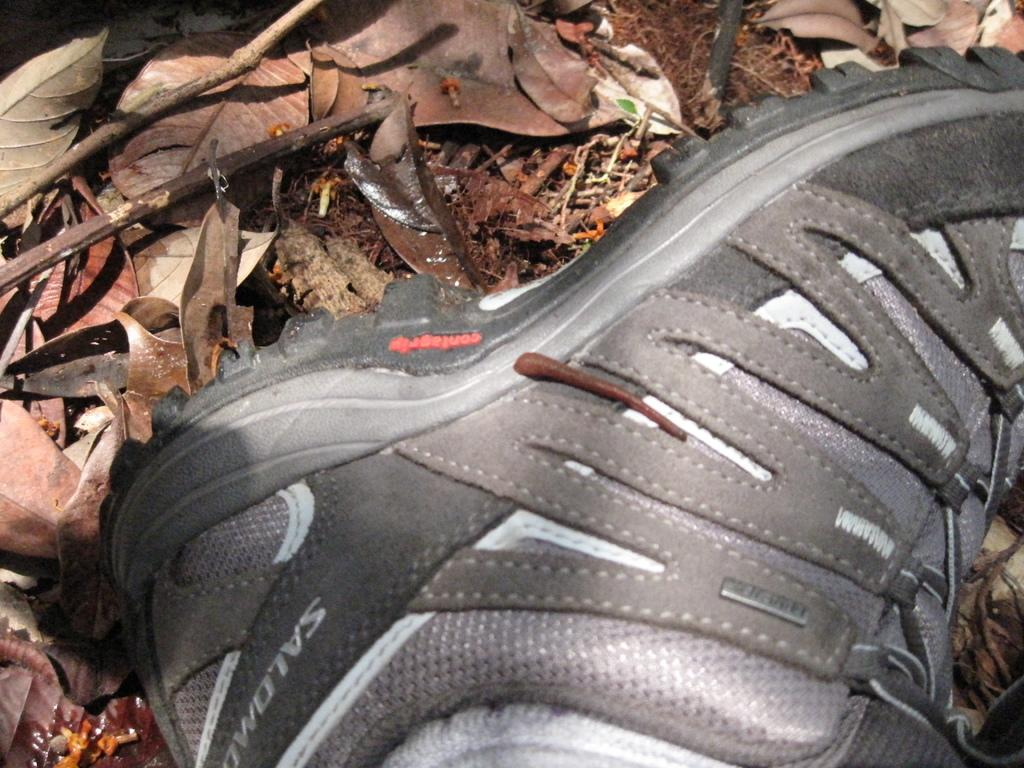What object can be seen in the image? There is a shoe in the image. What type of material is present in the image? There are shredded leaves in the image. Can you see the zephyr blowing the shoe in the image? There is no zephyr present in the image, and the shoe is not being blown by any wind. 